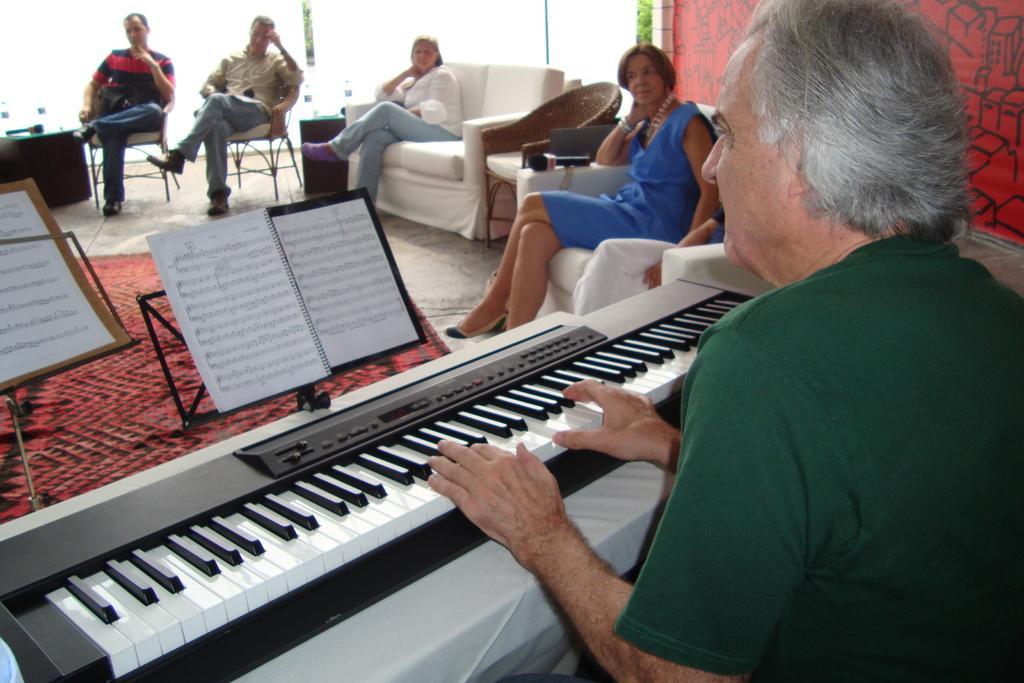Describe this image in one or two sentences. This picture is clicked inside a room. On the right corner of this picture, the man wearing green t-shirt is playing keyboard. He is having book in front of him and stand book stand and beside him, women in blue dress is sitting on the chair. Opposite to him, we see three people, two men and a woman sitting on chair and listening to him. Behind them, we see a glass door. 